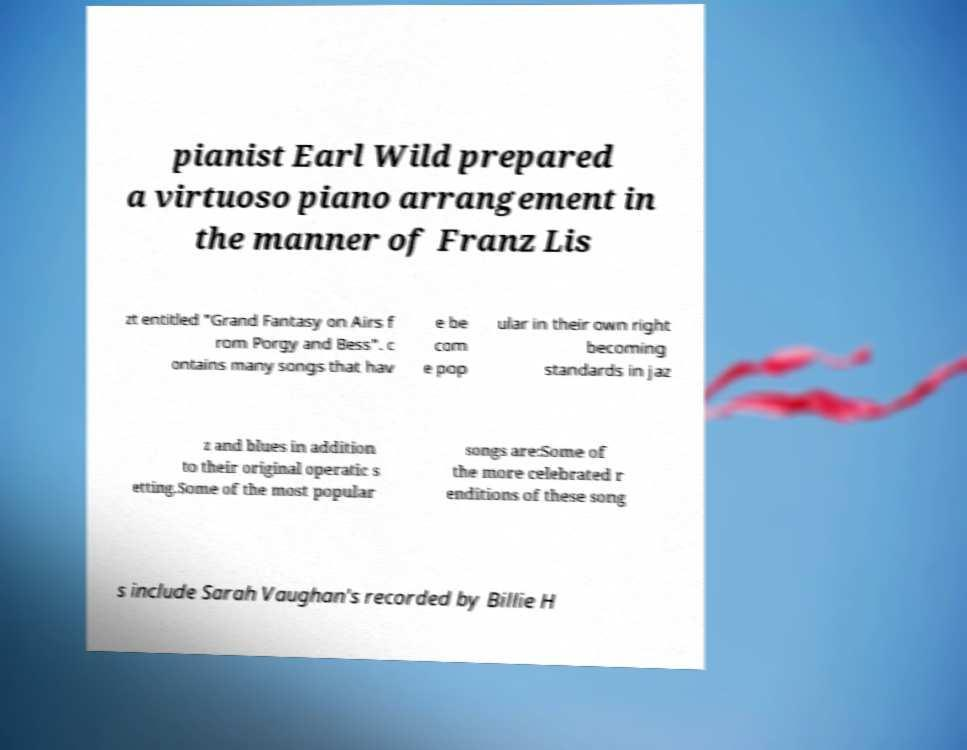There's text embedded in this image that I need extracted. Can you transcribe it verbatim? pianist Earl Wild prepared a virtuoso piano arrangement in the manner of Franz Lis zt entitled "Grand Fantasy on Airs f rom Porgy and Bess". c ontains many songs that hav e be com e pop ular in their own right becoming standards in jaz z and blues in addition to their original operatic s etting.Some of the most popular songs are:Some of the more celebrated r enditions of these song s include Sarah Vaughan's recorded by Billie H 